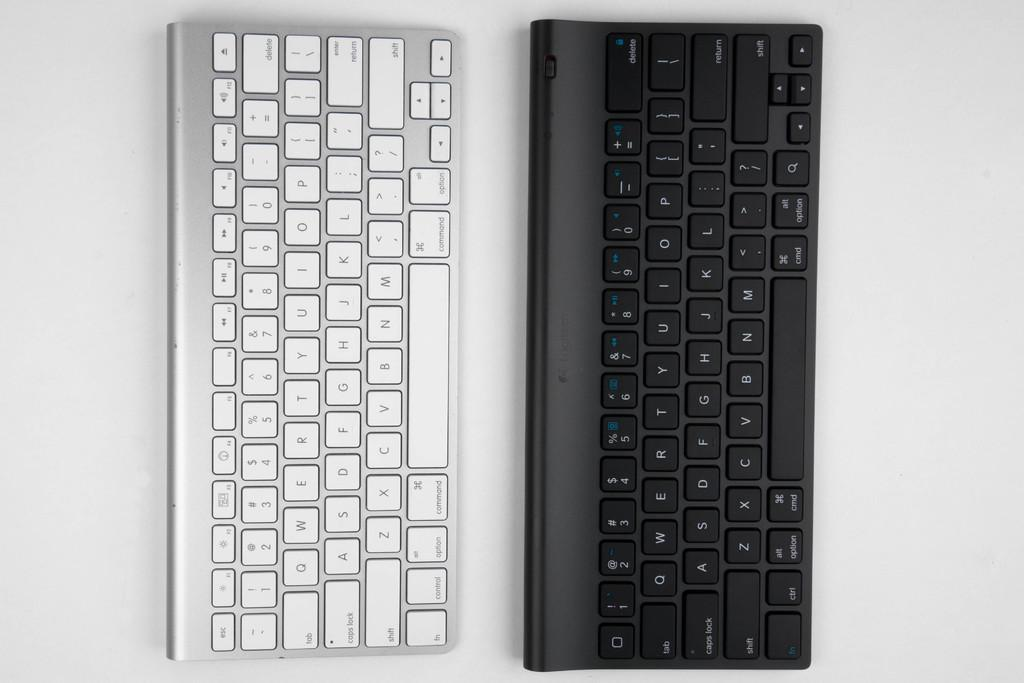How many keyboards are visible in the image? There are two keyboards in the image. What are the colors of the keyboards? One keyboard is white in color, and the other keyboard is black in color. How many cars are parked in front of the keyboards in the image? There are no cars present in the image; it only features two keyboards. 